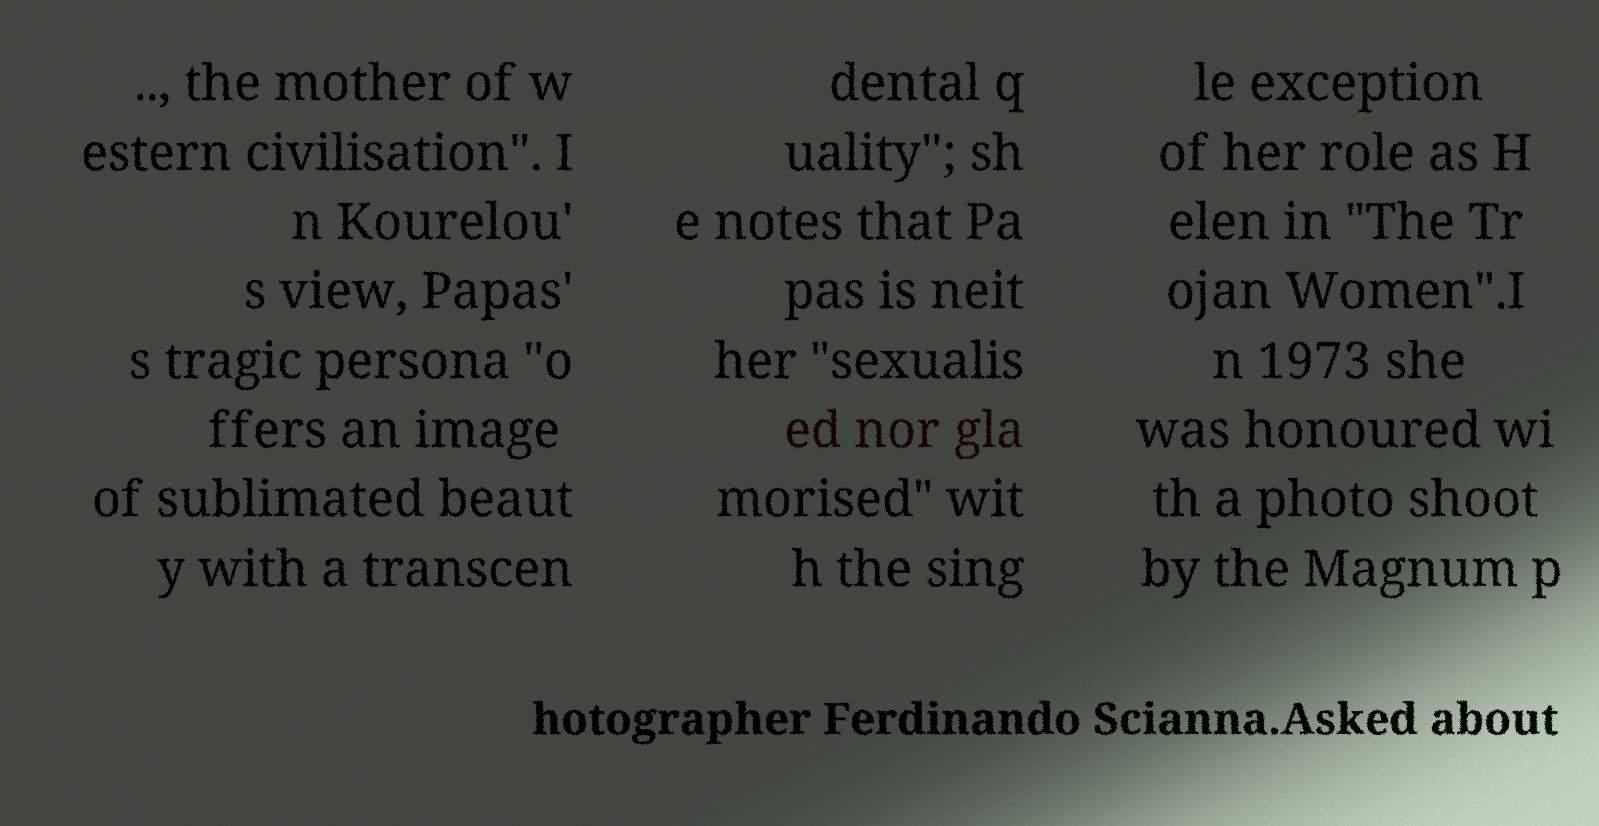Please read and relay the text visible in this image. What does it say? .., the mother of w estern civilisation". I n Kourelou' s view, Papas' s tragic persona "o ffers an image of sublimated beaut y with a transcen dental q uality"; sh e notes that Pa pas is neit her "sexualis ed nor gla morised" wit h the sing le exception of her role as H elen in "The Tr ojan Women".I n 1973 she was honoured wi th a photo shoot by the Magnum p hotographer Ferdinando Scianna.Asked about 